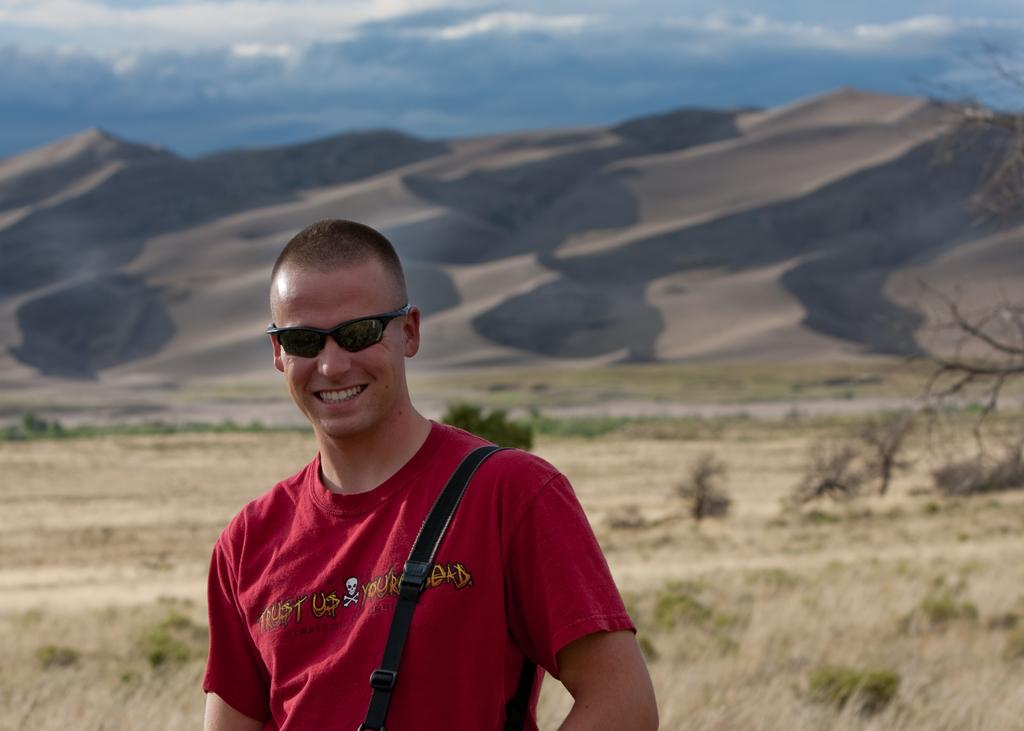Who is on the left side of the image? There is a man on the left side of the image. What can be seen in the background of the image? There is greenery in the background of the image. What is visible at the top of the image? The sky is visible at the top of the image. What type of disease is affecting the bird in the image? There is no bird present in the image, so it is not possible to determine if a disease is affecting it. 